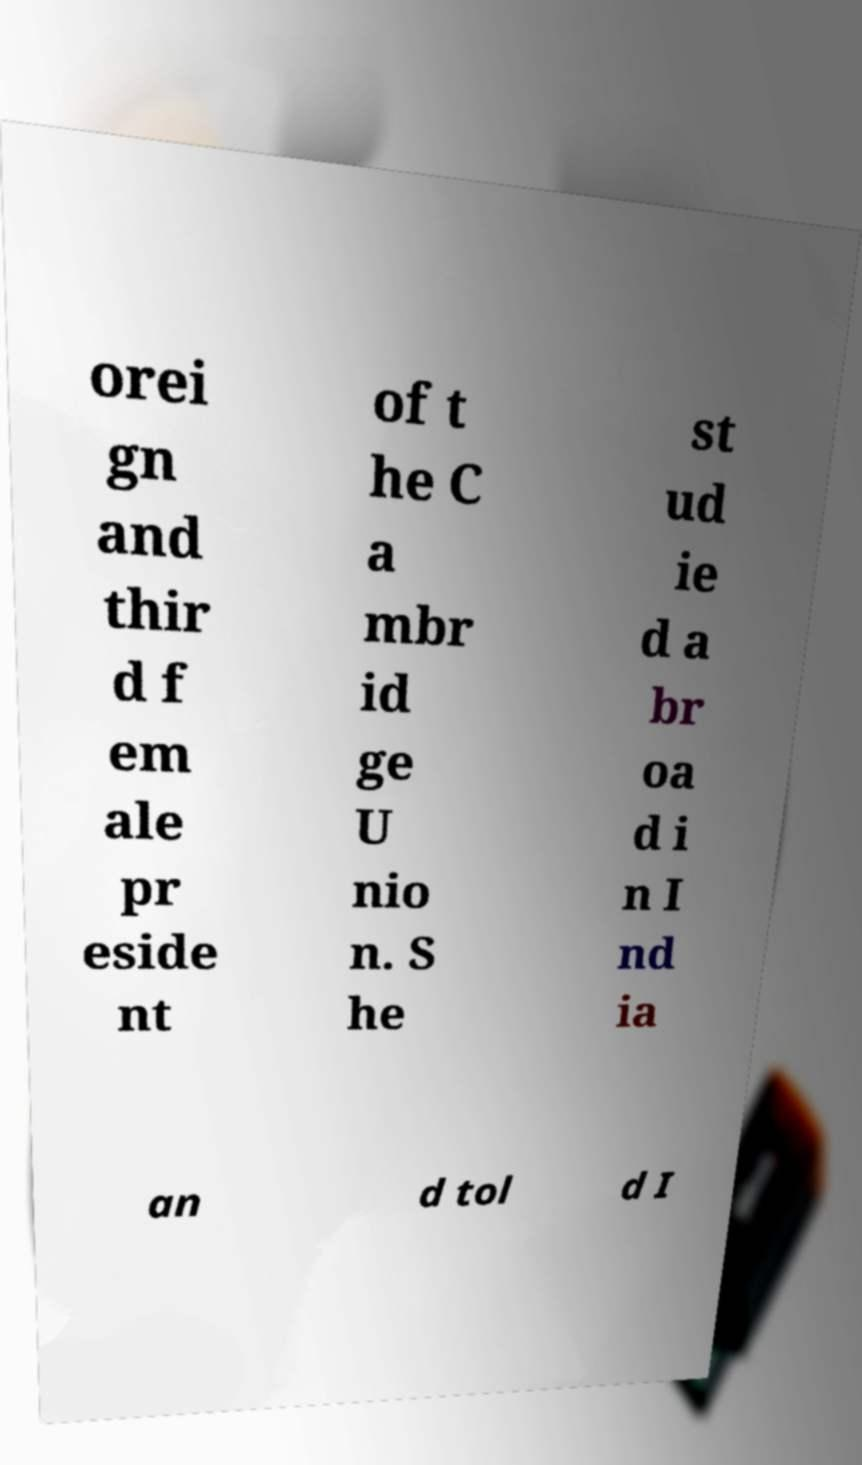Could you extract and type out the text from this image? orei gn and thir d f em ale pr eside nt of t he C a mbr id ge U nio n. S he st ud ie d a br oa d i n I nd ia an d tol d I 